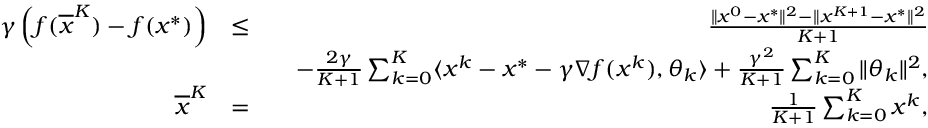Convert formula to latex. <formula><loc_0><loc_0><loc_500><loc_500>\begin{array} { r l r } { \gamma \left ( f ( \overline { x } ^ { K } ) - f ( x ^ { * } ) \right ) } & { \leq } & { \frac { \| x ^ { 0 } - x ^ { * } \| ^ { 2 } - \| x ^ { K + 1 } - x ^ { * } \| ^ { 2 } } { K + 1 } } \\ & { \quad - \frac { 2 \gamma } { K + 1 } \sum _ { k = 0 } ^ { K } \langle x ^ { k } - x ^ { * } - \gamma \nabla f ( x ^ { k } ) , \theta _ { k } \rangle + \frac { \gamma ^ { 2 } } { K + 1 } \sum _ { k = 0 } ^ { K } \| \theta _ { k } \| ^ { 2 } , } \\ { \overline { x } ^ { K } } & { = } & { \frac { 1 } { K + 1 } \sum _ { k = 0 } ^ { K } x ^ { k } , } \end{array}</formula> 